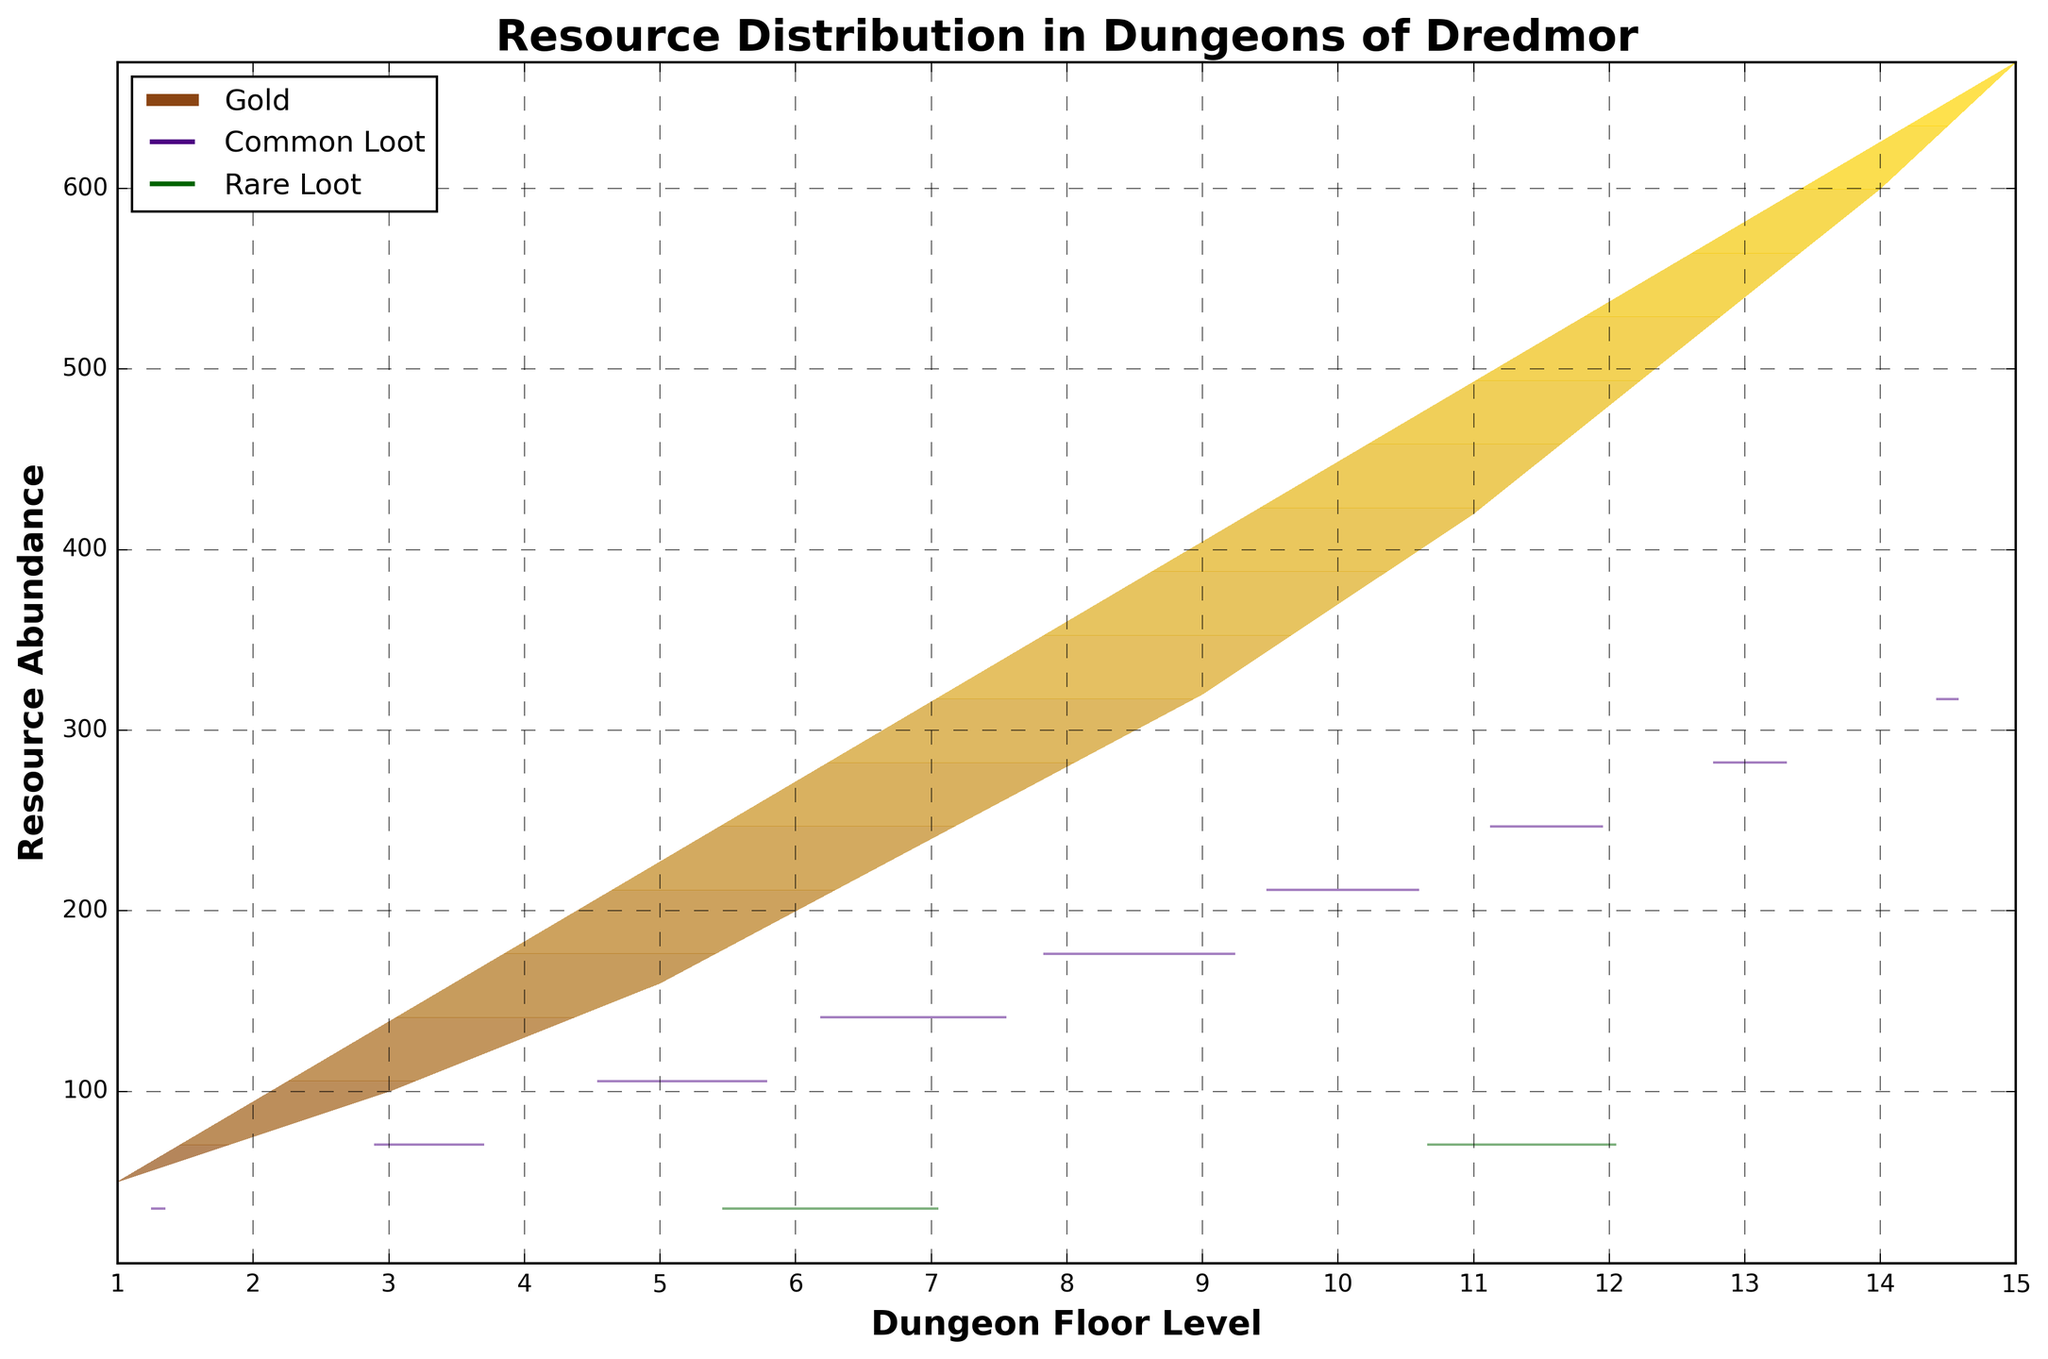what is the title of the plot? The title is written at the top of the plot. It describes what the figure is about. The title is 'Resource Distribution in Dungeons of Dredmor'.
Answer: Resource Distribution in Dungeons of Dredmor what are the labels of the axes? The labels of the axes are provided next to the respective axes. The x-axis is labeled 'Dungeon Floor Level', and the y-axis is labeled 'Resource Abundance'.
Answer: Dungeon Floor Level and Resource Abundance how does the abundance of gold change as you go deeper into the dungeon floors? Gold abundance increases as you go to deeper levels. This is evident from the contour plot where the gold values increase from lower to higher dungeon floor levels.
Answer: Increases which dungeon floor level has the highest rare loot abundance? The dungeon floor level with the highest rare loot abundance corresponds to the maximum y3 value. From visual inspection, floor level 15 has the highest rare loot.
Answer: Level 15 compare the gold abundance in dungeon floor levels 5 and 10. In the contour plot, the gold abundance at level 5 is around 160 units, while at level 10 it is around 370 units.
Answer: Level 10 has more gold than level 5 how many distinct color bands are used for gold in the contour plot? Count the number of distinct bands or contours used for gold color. There are approximately 4-5 distinct bands noticeable for gold.
Answer: 4-5 what pattern can be observed for common loot from level 1 to level 15? For common loot, the abundance increases as the dungeon floor level increases. This pattern is consistent and can be seen in the contour lines.
Answer: Increases is there any correlation between dungeon floor levels and resource abundance? From the plot, there is a positive correlation between dungeon floor levels and resource abundance for gold, common loot, and rare loot, as their amounts increase with deeper levels.
Answer: Positive correlation specifically, how is common loot distributed in the plot? The contour lines for common loot (in purple) show it's increasing more evenly across levels compared to rare loot. The purple lines spread vertically indicating more even distribution.
Answer: Evenly distributed 